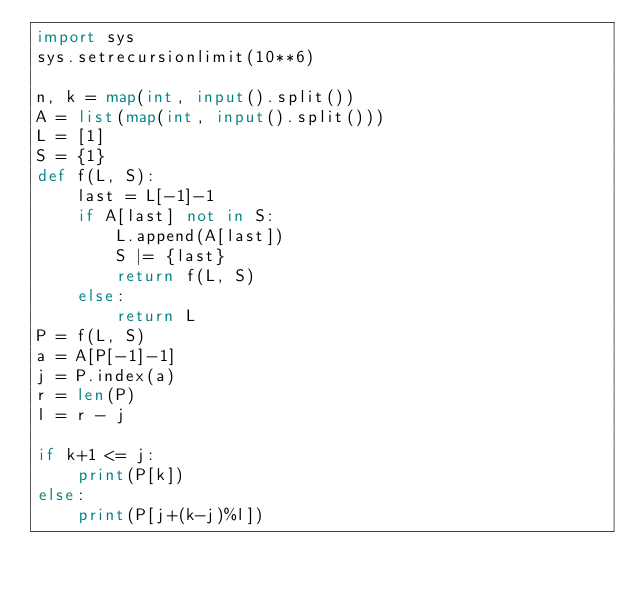Convert code to text. <code><loc_0><loc_0><loc_500><loc_500><_Python_>import sys
sys.setrecursionlimit(10**6)

n, k = map(int, input().split())
A = list(map(int, input().split()))
L = [1]
S = {1}
def f(L, S):
    last = L[-1]-1
    if A[last] not in S:
        L.append(A[last])
        S |= {last}
        return f(L, S)
    else:
        return L
P = f(L, S)
a = A[P[-1]-1]
j = P.index(a)
r = len(P)
l = r - j

if k+1 <= j:
    print(P[k])
else:
    print(P[j+(k-j)%l])</code> 